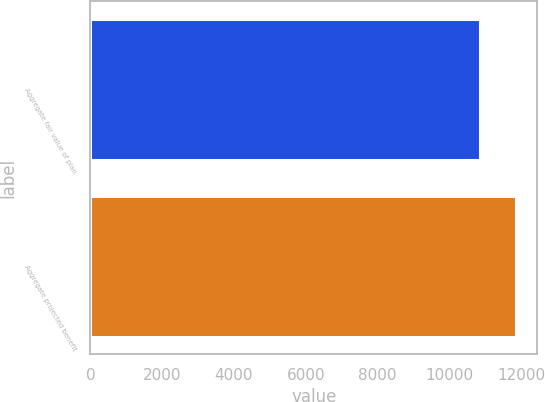Convert chart to OTSL. <chart><loc_0><loc_0><loc_500><loc_500><bar_chart><fcel>Aggregate fair value of plan<fcel>Aggregate projected benefit<nl><fcel>10866<fcel>11866<nl></chart> 